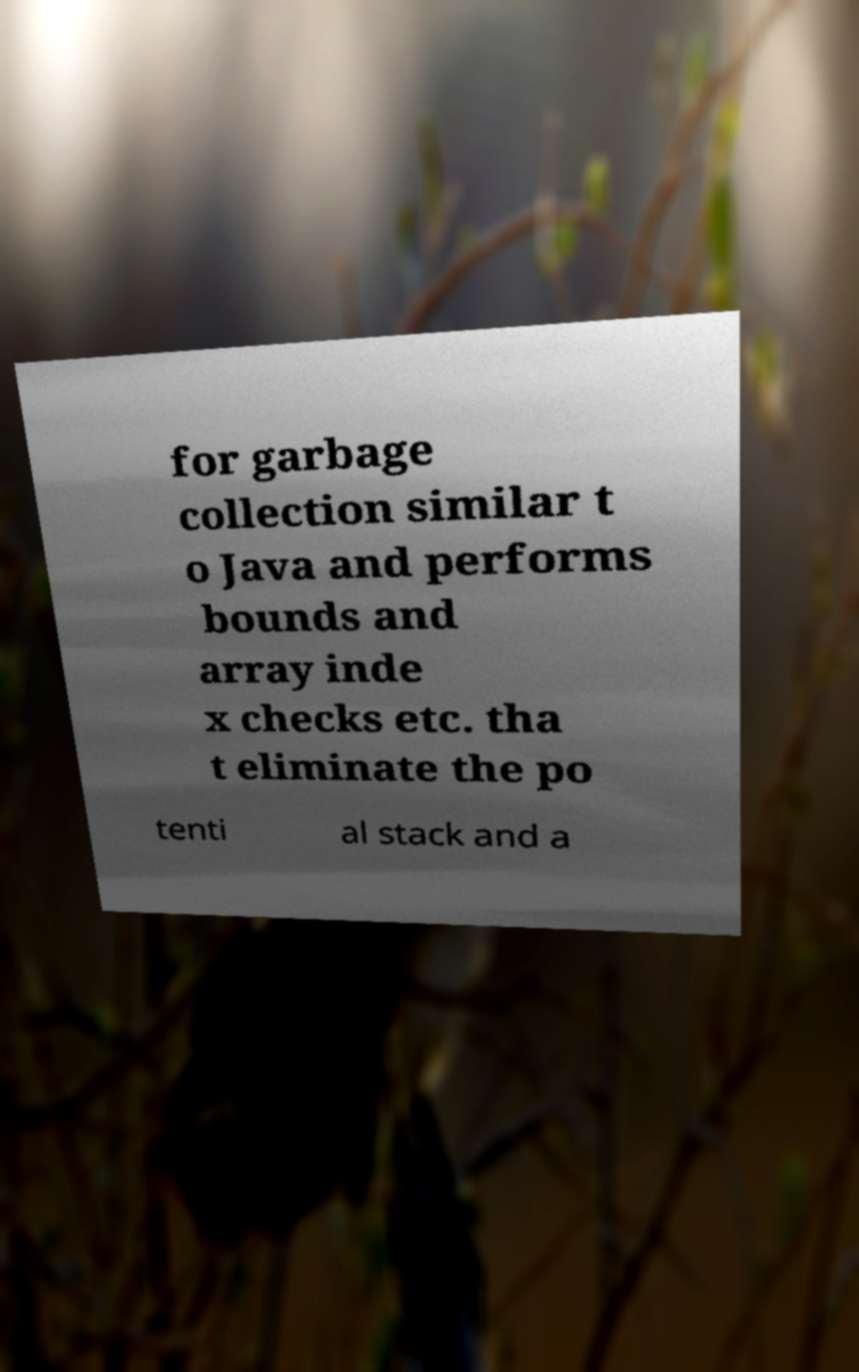Could you assist in decoding the text presented in this image and type it out clearly? for garbage collection similar t o Java and performs bounds and array inde x checks etc. tha t eliminate the po tenti al stack and a 